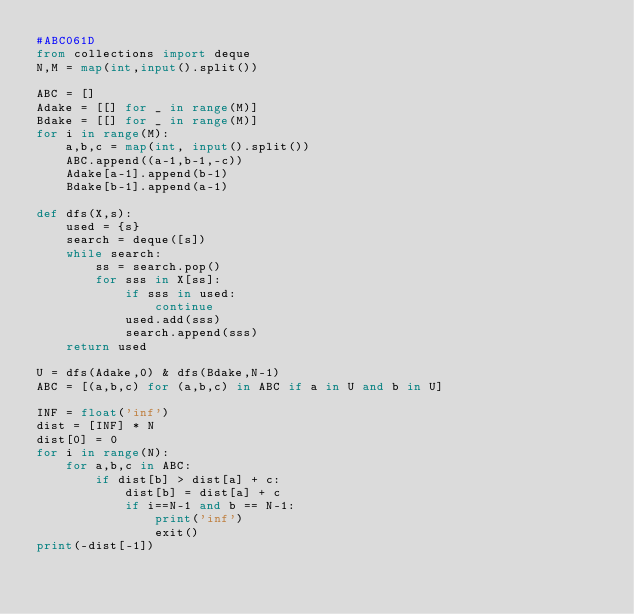Convert code to text. <code><loc_0><loc_0><loc_500><loc_500><_Python_>#ABC061D
from collections import deque
N,M = map(int,input().split())

ABC = []
Adake = [[] for _ in range(M)]
Bdake = [[] for _ in range(M)]
for i in range(M):
    a,b,c = map(int, input().split())
    ABC.append((a-1,b-1,-c))
    Adake[a-1].append(b-1)
    Bdake[b-1].append(a-1)

def dfs(X,s):
    used = {s}
    search = deque([s])
    while search:
        ss = search.pop()
        for sss in X[ss]:
            if sss in used:
                continue
            used.add(sss)
            search.append(sss)
    return used

U = dfs(Adake,0) & dfs(Bdake,N-1)
ABC = [(a,b,c) for (a,b,c) in ABC if a in U and b in U]

INF = float('inf')
dist = [INF] * N
dist[0] = 0
for i in range(N):
    for a,b,c in ABC:
        if dist[b] > dist[a] + c:
            dist[b] = dist[a] + c
            if i==N-1 and b == N-1:
                print('inf')
                exit()
print(-dist[-1])</code> 